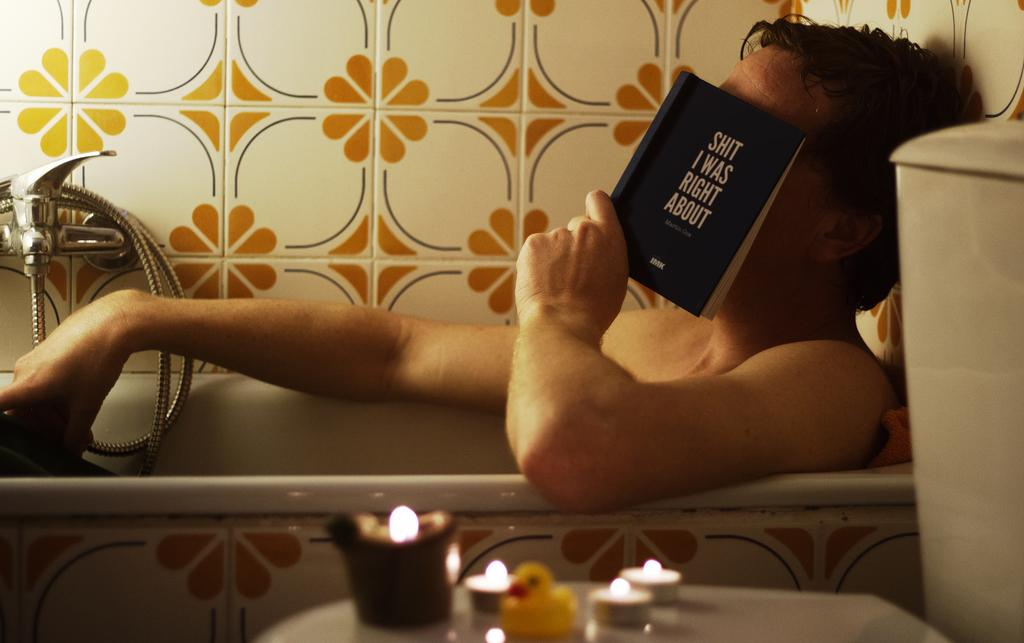<image>
Give a short and clear explanation of the subsequent image. A man laying in a bathtub with the book Shit I Was Right About fanned over his face. 